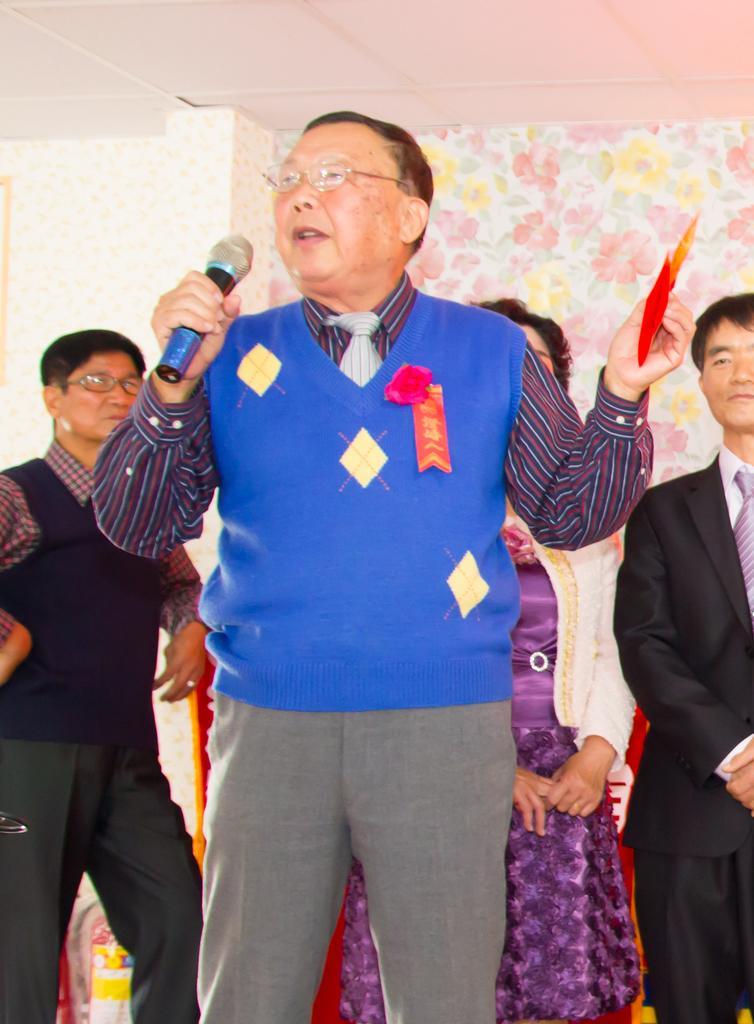Can you describe this image briefly? In this image we can see a person holding a microphone and an object. In the background of the image there are some persons, wall and other objects. At the top of the image there is the ceiling. 